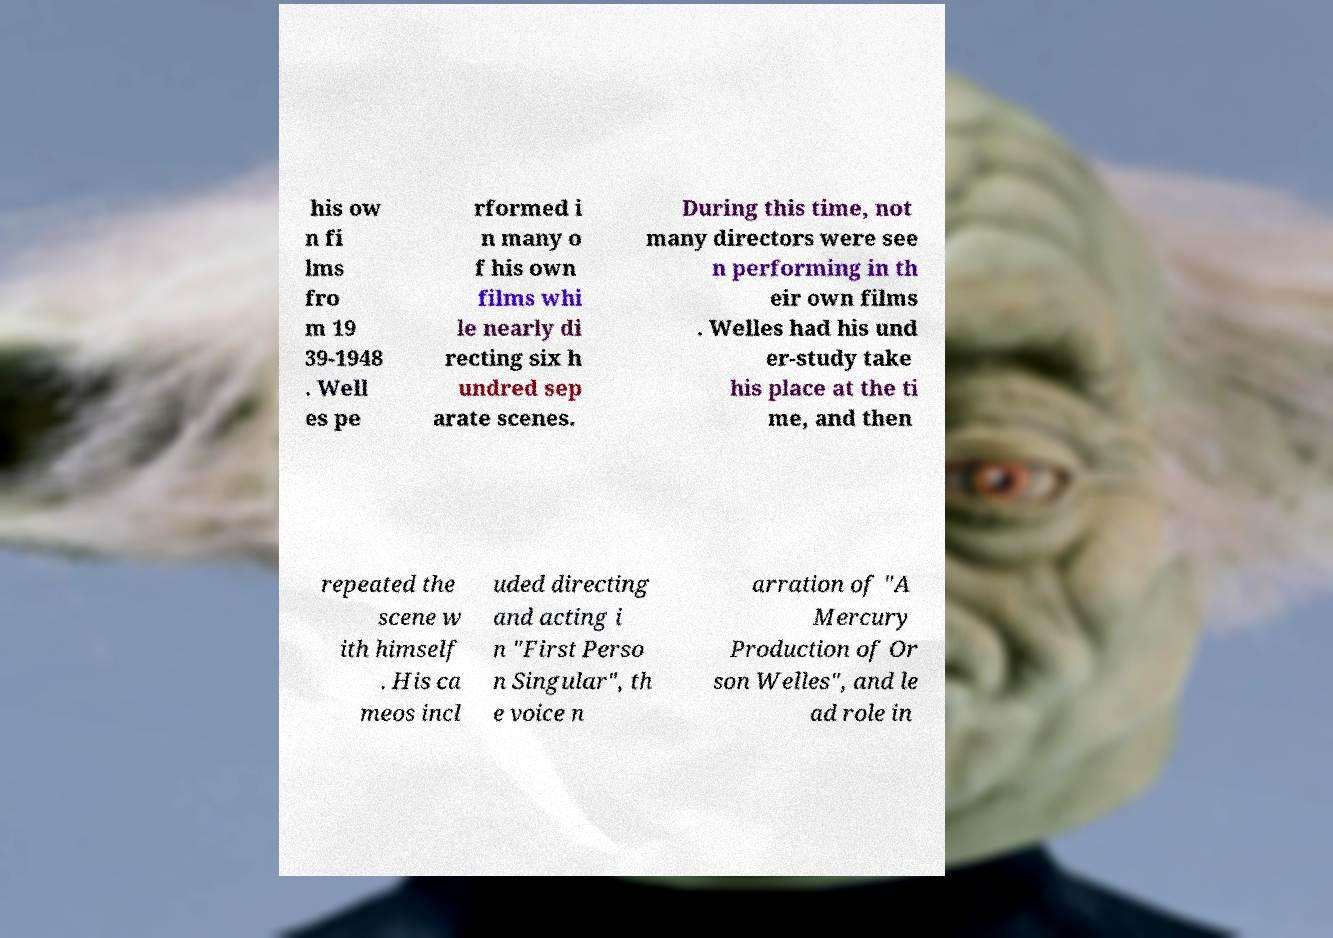For documentation purposes, I need the text within this image transcribed. Could you provide that? his ow n fi lms fro m 19 39-1948 . Well es pe rformed i n many o f his own films whi le nearly di recting six h undred sep arate scenes. During this time, not many directors were see n performing in th eir own films . Welles had his und er-study take his place at the ti me, and then repeated the scene w ith himself . His ca meos incl uded directing and acting i n "First Perso n Singular", th e voice n arration of "A Mercury Production of Or son Welles", and le ad role in 